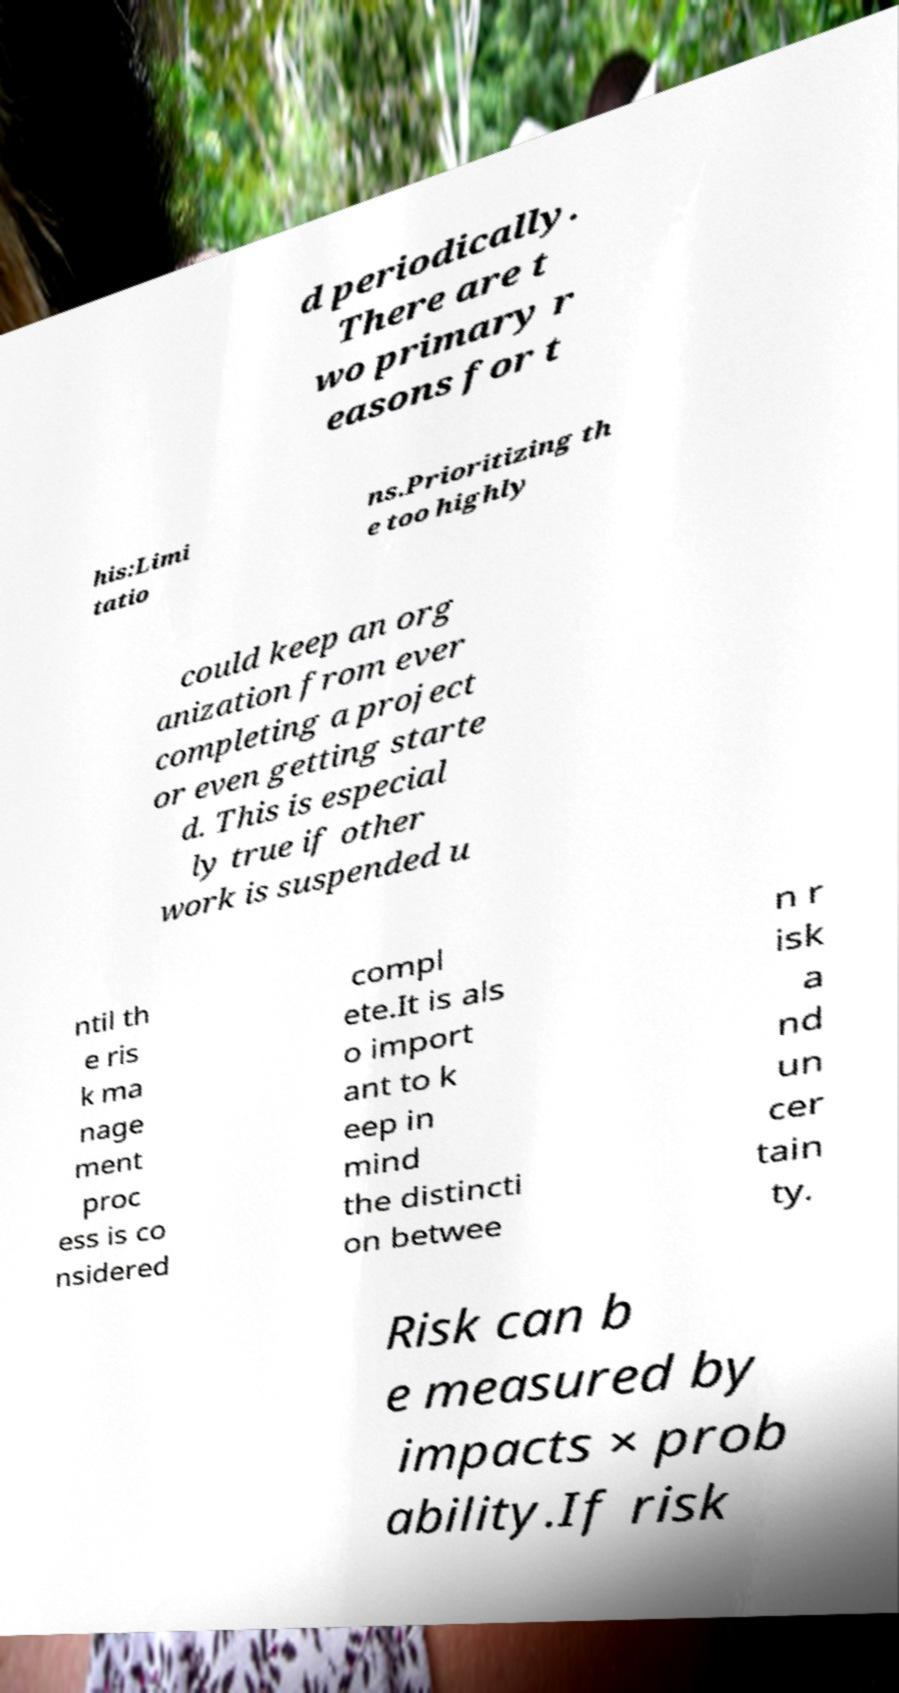Could you extract and type out the text from this image? d periodically. There are t wo primary r easons for t his:Limi tatio ns.Prioritizing th e too highly could keep an org anization from ever completing a project or even getting starte d. This is especial ly true if other work is suspended u ntil th e ris k ma nage ment proc ess is co nsidered compl ete.It is als o import ant to k eep in mind the distincti on betwee n r isk a nd un cer tain ty. Risk can b e measured by impacts × prob ability.If risk 